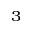Convert formula to latex. <formula><loc_0><loc_0><loc_500><loc_500>^ { 3 }</formula> 